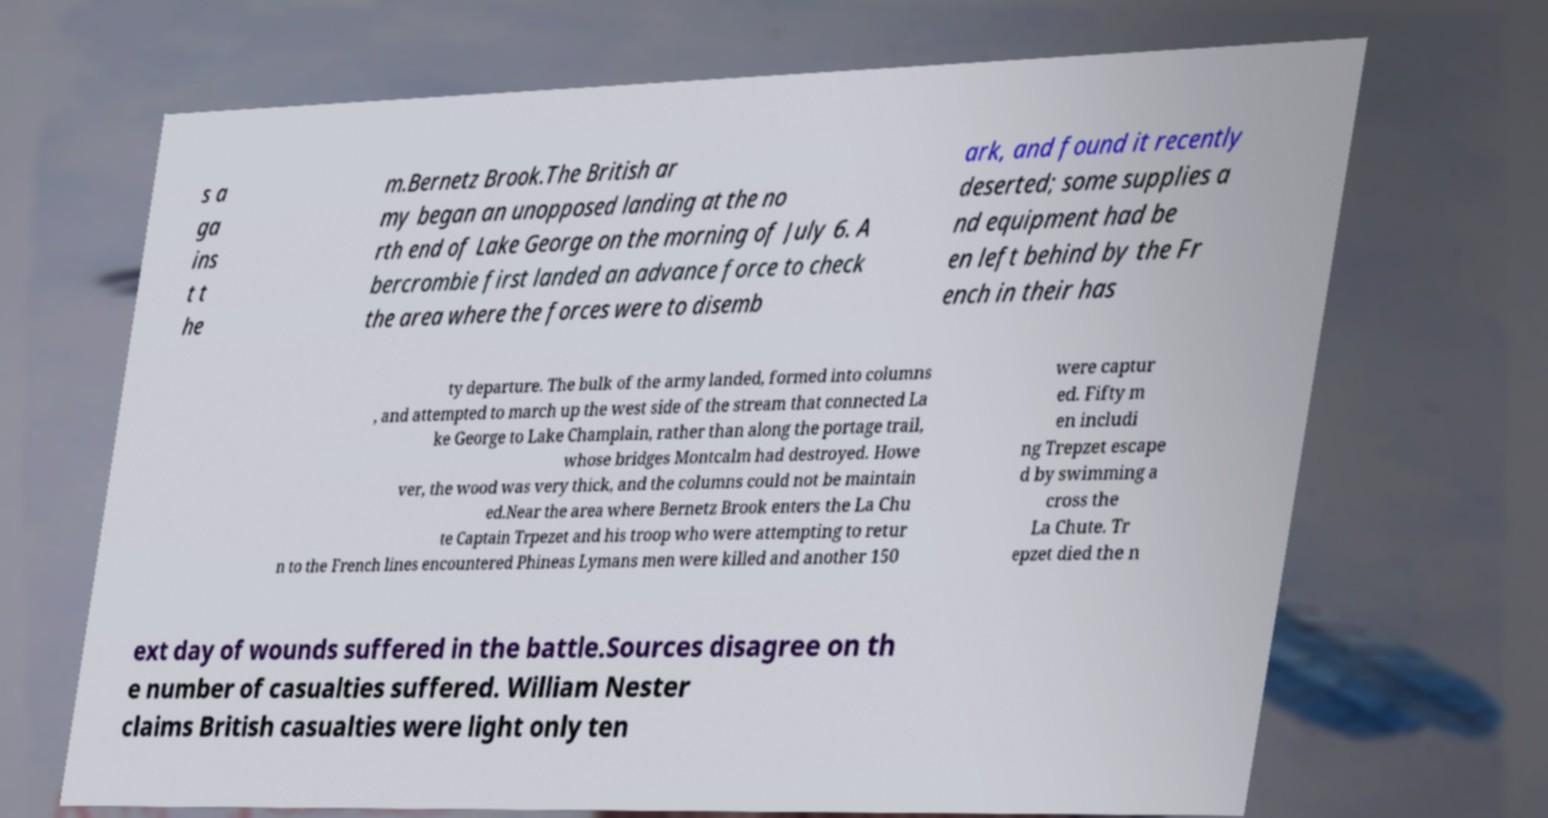Could you assist in decoding the text presented in this image and type it out clearly? s a ga ins t t he m.Bernetz Brook.The British ar my began an unopposed landing at the no rth end of Lake George on the morning of July 6. A bercrombie first landed an advance force to check the area where the forces were to disemb ark, and found it recently deserted; some supplies a nd equipment had be en left behind by the Fr ench in their has ty departure. The bulk of the army landed, formed into columns , and attempted to march up the west side of the stream that connected La ke George to Lake Champlain, rather than along the portage trail, whose bridges Montcalm had destroyed. Howe ver, the wood was very thick, and the columns could not be maintain ed.Near the area where Bernetz Brook enters the La Chu te Captain Trpezet and his troop who were attempting to retur n to the French lines encountered Phineas Lymans men were killed and another 150 were captur ed. Fifty m en includi ng Trepzet escape d by swimming a cross the La Chute. Tr epzet died the n ext day of wounds suffered in the battle.Sources disagree on th e number of casualties suffered. William Nester claims British casualties were light only ten 